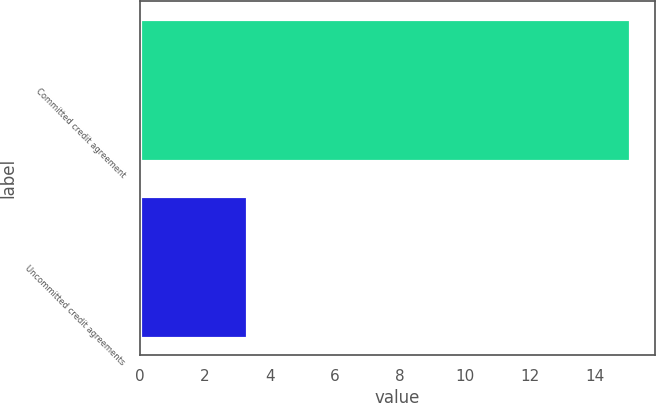Convert chart. <chart><loc_0><loc_0><loc_500><loc_500><bar_chart><fcel>Committed credit agreement<fcel>Uncommitted credit agreements<nl><fcel>15.1<fcel>3.3<nl></chart> 